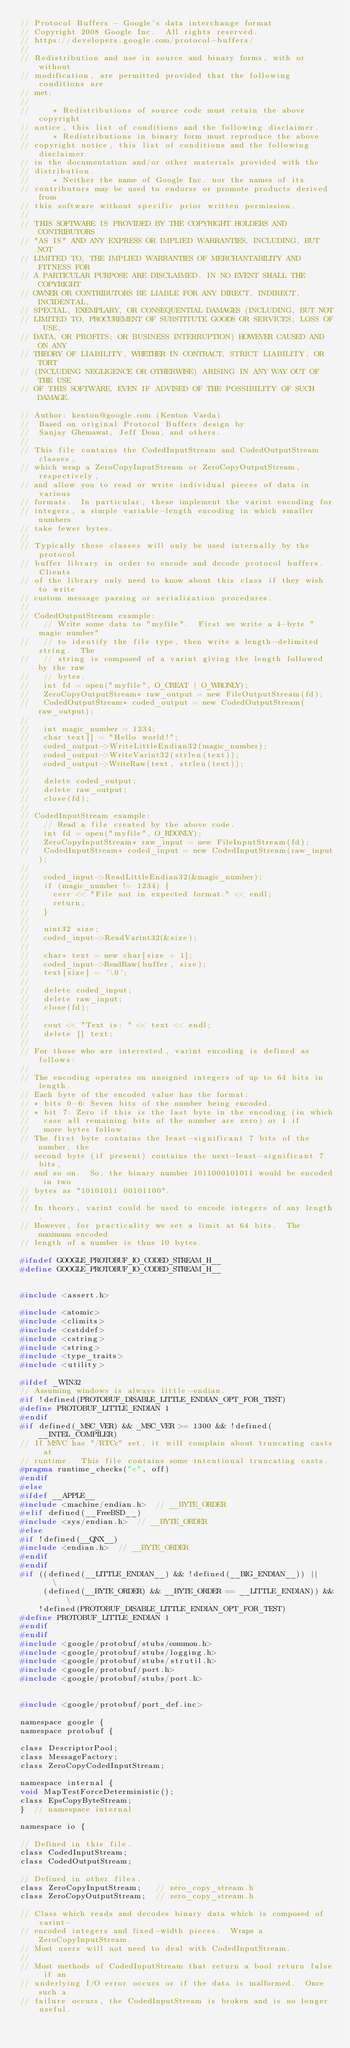Convert code to text. <code><loc_0><loc_0><loc_500><loc_500><_C_>// Protocol Buffers - Google's data interchange format
// Copyright 2008 Google Inc.  All rights reserved.
// https://developers.google.com/protocol-buffers/
//
// Redistribution and use in source and binary forms, with or without
// modification, are permitted provided that the following conditions are
// met:
//
//     * Redistributions of source code must retain the above copyright
// notice, this list of conditions and the following disclaimer.
//     * Redistributions in binary form must reproduce the above
// copyright notice, this list of conditions and the following disclaimer
// in the documentation and/or other materials provided with the
// distribution.
//     * Neither the name of Google Inc. nor the names of its
// contributors may be used to endorse or promote products derived from
// this software without specific prior written permission.
//
// THIS SOFTWARE IS PROVIDED BY THE COPYRIGHT HOLDERS AND CONTRIBUTORS
// "AS IS" AND ANY EXPRESS OR IMPLIED WARRANTIES, INCLUDING, BUT NOT
// LIMITED TO, THE IMPLIED WARRANTIES OF MERCHANTABILITY AND FITNESS FOR
// A PARTICULAR PURPOSE ARE DISCLAIMED. IN NO EVENT SHALL THE COPYRIGHT
// OWNER OR CONTRIBUTORS BE LIABLE FOR ANY DIRECT, INDIRECT, INCIDENTAL,
// SPECIAL, EXEMPLARY, OR CONSEQUENTIAL DAMAGES (INCLUDING, BUT NOT
// LIMITED TO, PROCUREMENT OF SUBSTITUTE GOODS OR SERVICES; LOSS OF USE,
// DATA, OR PROFITS; OR BUSINESS INTERRUPTION) HOWEVER CAUSED AND ON ANY
// THEORY OF LIABILITY, WHETHER IN CONTRACT, STRICT LIABILITY, OR TORT
// (INCLUDING NEGLIGENCE OR OTHERWISE) ARISING IN ANY WAY OUT OF THE USE
// OF THIS SOFTWARE, EVEN IF ADVISED OF THE POSSIBILITY OF SUCH DAMAGE.

// Author: kenton@google.com (Kenton Varda)
//  Based on original Protocol Buffers design by
//  Sanjay Ghemawat, Jeff Dean, and others.
//
// This file contains the CodedInputStream and CodedOutputStream classes,
// which wrap a ZeroCopyInputStream or ZeroCopyOutputStream, respectively,
// and allow you to read or write individual pieces of data in various
// formats.  In particular, these implement the varint encoding for
// integers, a simple variable-length encoding in which smaller numbers
// take fewer bytes.
//
// Typically these classes will only be used internally by the protocol
// buffer library in order to encode and decode protocol buffers.  Clients
// of the library only need to know about this class if they wish to write
// custom message parsing or serialization procedures.
//
// CodedOutputStream example:
//   // Write some data to "myfile".  First we write a 4-byte "magic number"
//   // to identify the file type, then write a length-delimited string.  The
//   // string is composed of a varint giving the length followed by the raw
//   // bytes.
//   int fd = open("myfile", O_CREAT | O_WRONLY);
//   ZeroCopyOutputStream* raw_output = new FileOutputStream(fd);
//   CodedOutputStream* coded_output = new CodedOutputStream(raw_output);
//
//   int magic_number = 1234;
//   char text[] = "Hello world!";
//   coded_output->WriteLittleEndian32(magic_number);
//   coded_output->WriteVarint32(strlen(text));
//   coded_output->WriteRaw(text, strlen(text));
//
//   delete coded_output;
//   delete raw_output;
//   close(fd);
//
// CodedInputStream example:
//   // Read a file created by the above code.
//   int fd = open("myfile", O_RDONLY);
//   ZeroCopyInputStream* raw_input = new FileInputStream(fd);
//   CodedInputStream* coded_input = new CodedInputStream(raw_input);
//
//   coded_input->ReadLittleEndian32(&magic_number);
//   if (magic_number != 1234) {
//     cerr << "File not in expected format." << endl;
//     return;
//   }
//
//   uint32 size;
//   coded_input->ReadVarint32(&size);
//
//   char* text = new char[size + 1];
//   coded_input->ReadRaw(buffer, size);
//   text[size] = '\0';
//
//   delete coded_input;
//   delete raw_input;
//   close(fd);
//
//   cout << "Text is: " << text << endl;
//   delete [] text;
//
// For those who are interested, varint encoding is defined as follows:
//
// The encoding operates on unsigned integers of up to 64 bits in length.
// Each byte of the encoded value has the format:
// * bits 0-6: Seven bits of the number being encoded.
// * bit 7: Zero if this is the last byte in the encoding (in which
//   case all remaining bits of the number are zero) or 1 if
//   more bytes follow.
// The first byte contains the least-significant 7 bits of the number, the
// second byte (if present) contains the next-least-significant 7 bits,
// and so on.  So, the binary number 1011000101011 would be encoded in two
// bytes as "10101011 00101100".
//
// In theory, varint could be used to encode integers of any length.
// However, for practicality we set a limit at 64 bits.  The maximum encoded
// length of a number is thus 10 bytes.

#ifndef GOOGLE_PROTOBUF_IO_CODED_STREAM_H__
#define GOOGLE_PROTOBUF_IO_CODED_STREAM_H__


#include <assert.h>

#include <atomic>
#include <climits>
#include <cstddef>
#include <cstring>
#include <string>
#include <type_traits>
#include <utility>

#ifdef _WIN32
// Assuming windows is always little-endian.
#if !defined(PROTOBUF_DISABLE_LITTLE_ENDIAN_OPT_FOR_TEST)
#define PROTOBUF_LITTLE_ENDIAN 1
#endif
#if defined(_MSC_VER) && _MSC_VER >= 1300 && !defined(__INTEL_COMPILER)
// If MSVC has "/RTCc" set, it will complain about truncating casts at
// runtime.  This file contains some intentional truncating casts.
#pragma runtime_checks("c", off)
#endif
#else
#ifdef __APPLE__
#include <machine/endian.h>  // __BYTE_ORDER
#elif defined(__FreeBSD__)
#include <sys/endian.h>  // __BYTE_ORDER
#else
#if !defined(__QNX__)
#include <endian.h>  // __BYTE_ORDER
#endif
#endif
#if ((defined(__LITTLE_ENDIAN__) && !defined(__BIG_ENDIAN__)) ||    \
     (defined(__BYTE_ORDER) && __BYTE_ORDER == __LITTLE_ENDIAN)) && \
    !defined(PROTOBUF_DISABLE_LITTLE_ENDIAN_OPT_FOR_TEST)
#define PROTOBUF_LITTLE_ENDIAN 1
#endif
#endif
#include <google/protobuf/stubs/common.h>
#include <google/protobuf/stubs/logging.h>
#include <google/protobuf/stubs/strutil.h>
#include <google/protobuf/port.h>
#include <google/protobuf/stubs/port.h>


#include <google/protobuf/port_def.inc>

namespace google {
namespace protobuf {

class DescriptorPool;
class MessageFactory;
class ZeroCopyCodedInputStream;

namespace internal {
void MapTestForceDeterministic();
class EpsCopyByteStream;
}  // namespace internal

namespace io {

// Defined in this file.
class CodedInputStream;
class CodedOutputStream;

// Defined in other files.
class ZeroCopyInputStream;   // zero_copy_stream.h
class ZeroCopyOutputStream;  // zero_copy_stream.h

// Class which reads and decodes binary data which is composed of varint-
// encoded integers and fixed-width pieces.  Wraps a ZeroCopyInputStream.
// Most users will not need to deal with CodedInputStream.
//
// Most methods of CodedInputStream that return a bool return false if an
// underlying I/O error occurs or if the data is malformed.  Once such a
// failure occurs, the CodedInputStream is broken and is no longer useful.</code> 